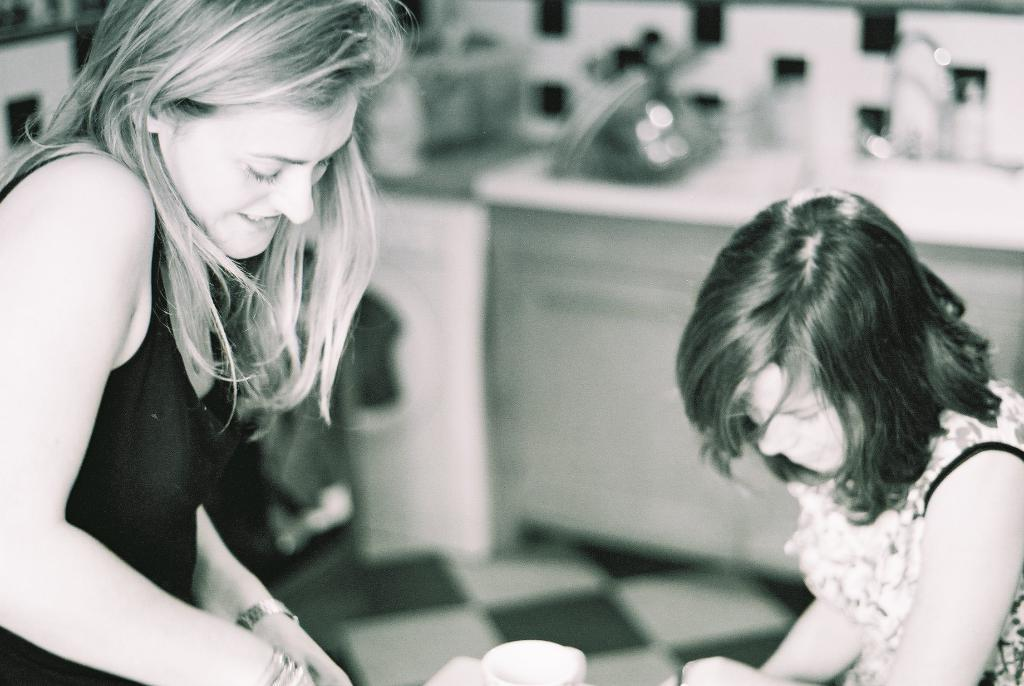What is the color scheme of the image? The image is black and white. Where is the girl located in the image? The girl is on the left side of the image. Where is the kid located in the image? The kid is on the right side of the image. What object is present between the girl and the kid? There is a cup between the girl and the kid. What type of leather is the fireman using to slide down the pole in the image? There is no fireman or leather present in the image. What is the relation between the girl and the kid in the image? The provided facts do not mention the relationship between the girl and the kid. 